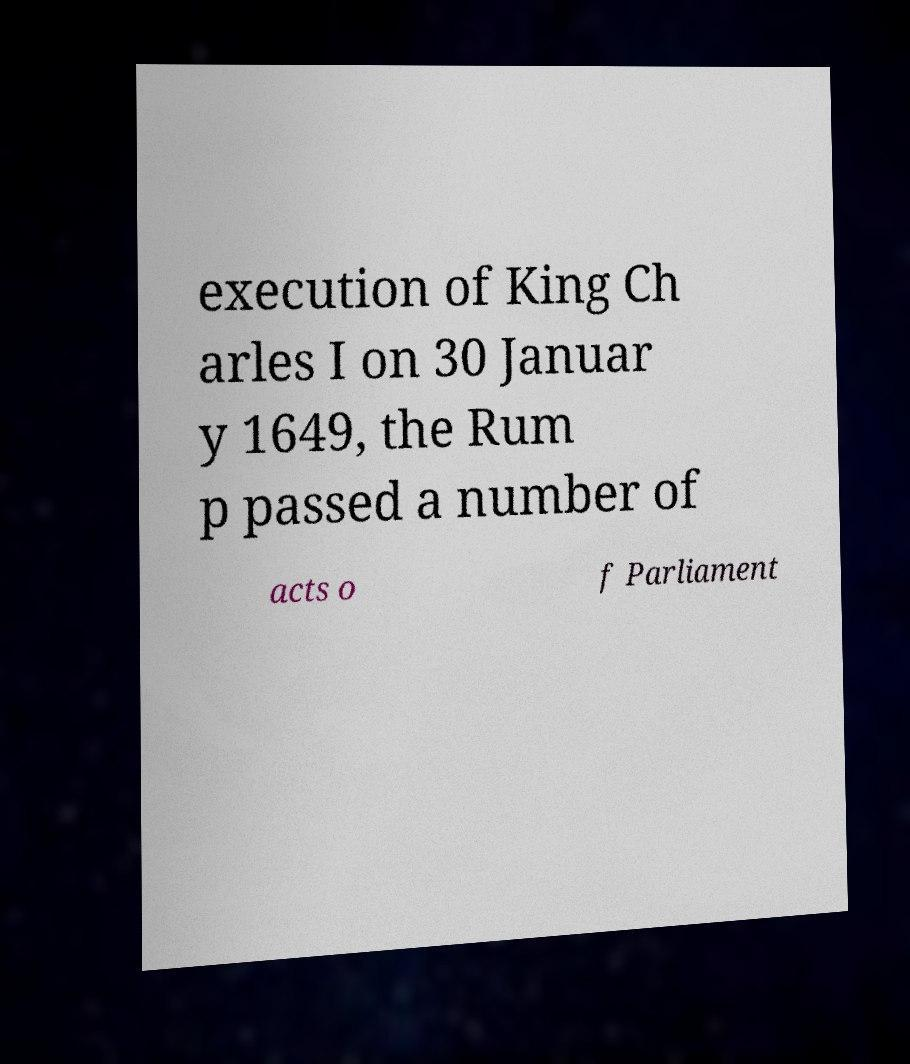Can you accurately transcribe the text from the provided image for me? execution of King Ch arles I on 30 Januar y 1649, the Rum p passed a number of acts o f Parliament 